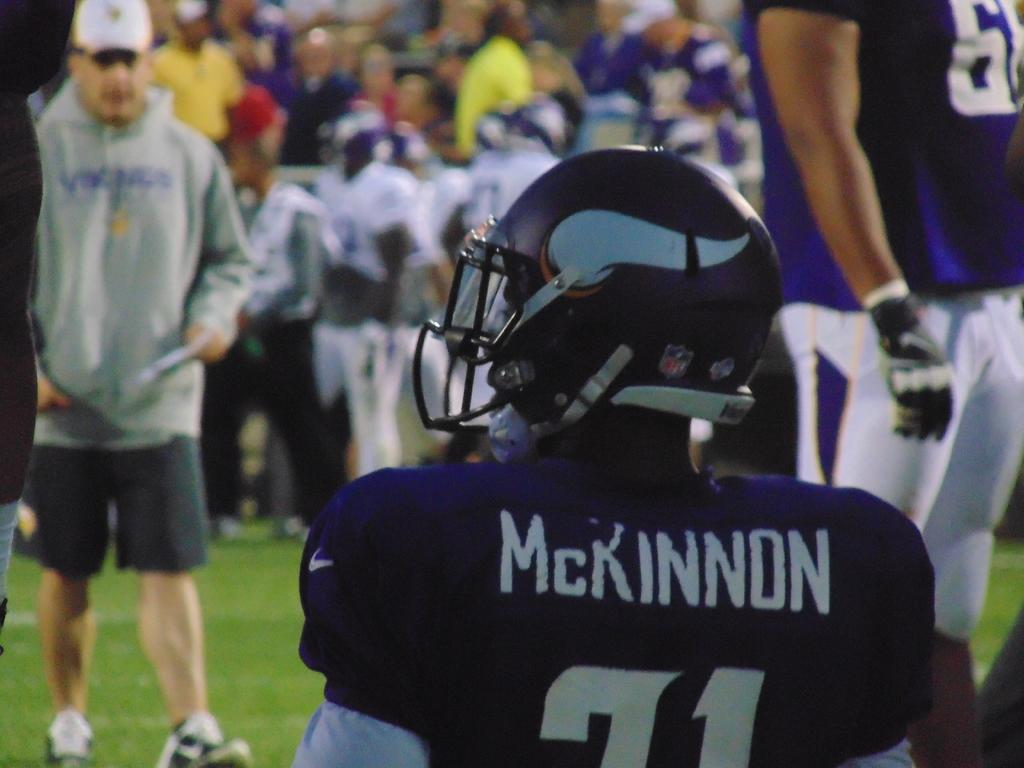What is the person in the image doing? The person is sitting in the image. What is the person wearing on their head? The person is wearing a helmet. What type of environment is visible in the image? There is grass visible in the image. Are there any other people present in the image? Yes, there are surrounding people in the image. What type of nut is the person holding in the image? There is no nut visible in the image; the person is wearing a helmet. Can you see any chickens in the image? No, there are no chickens present in the image. 